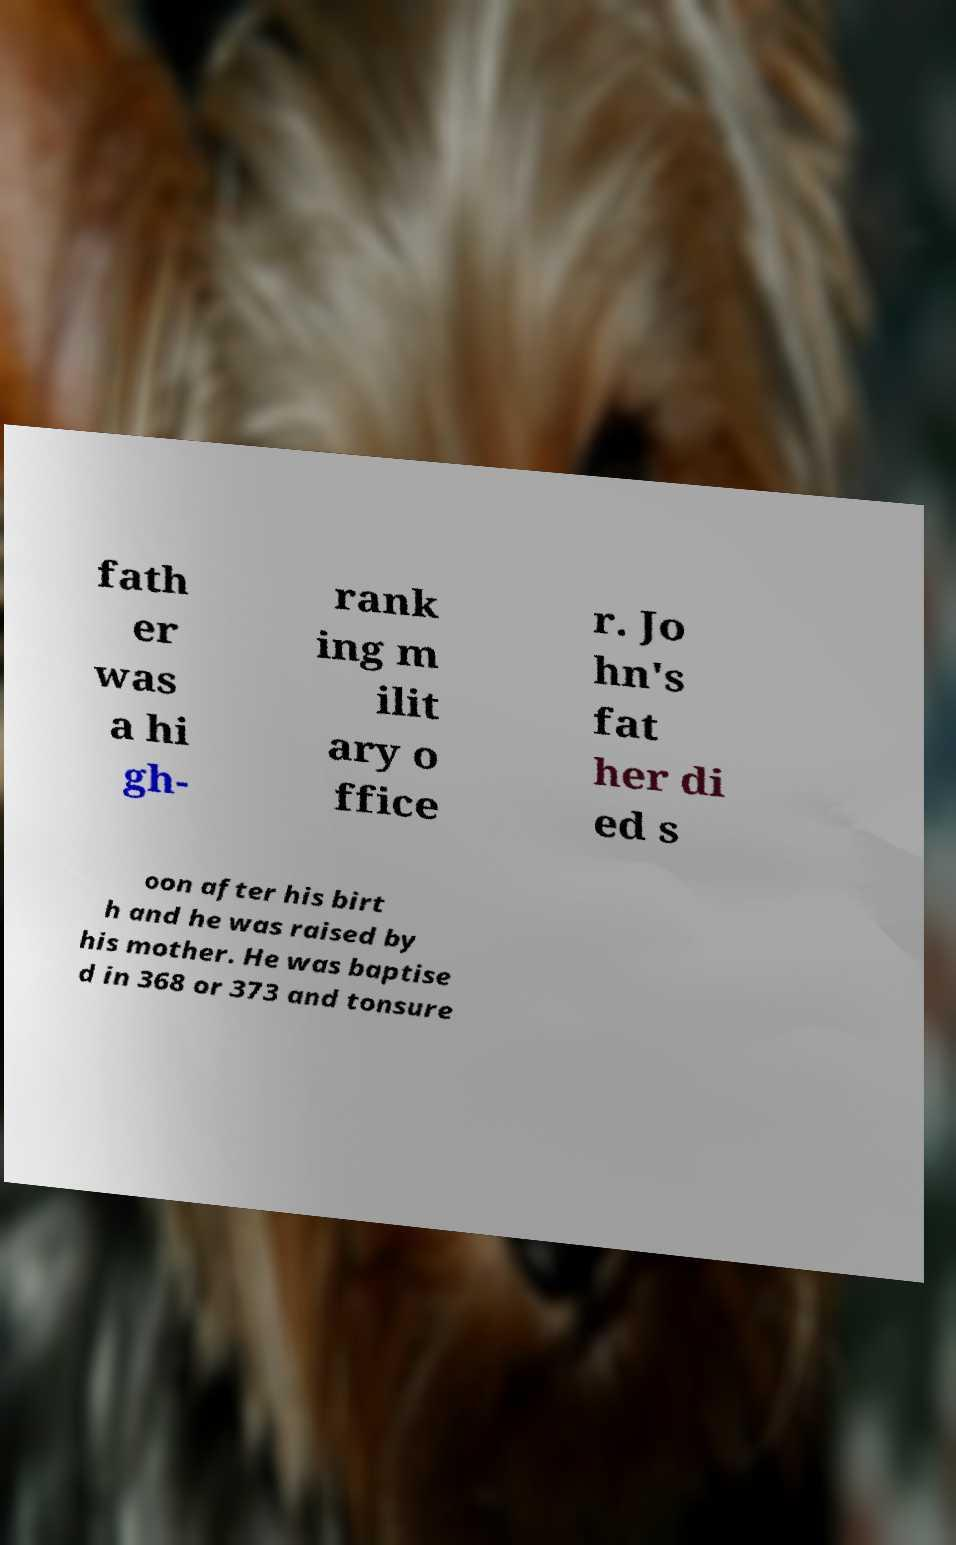There's text embedded in this image that I need extracted. Can you transcribe it verbatim? fath er was a hi gh- rank ing m ilit ary o ffice r. Jo hn's fat her di ed s oon after his birt h and he was raised by his mother. He was baptise d in 368 or 373 and tonsure 